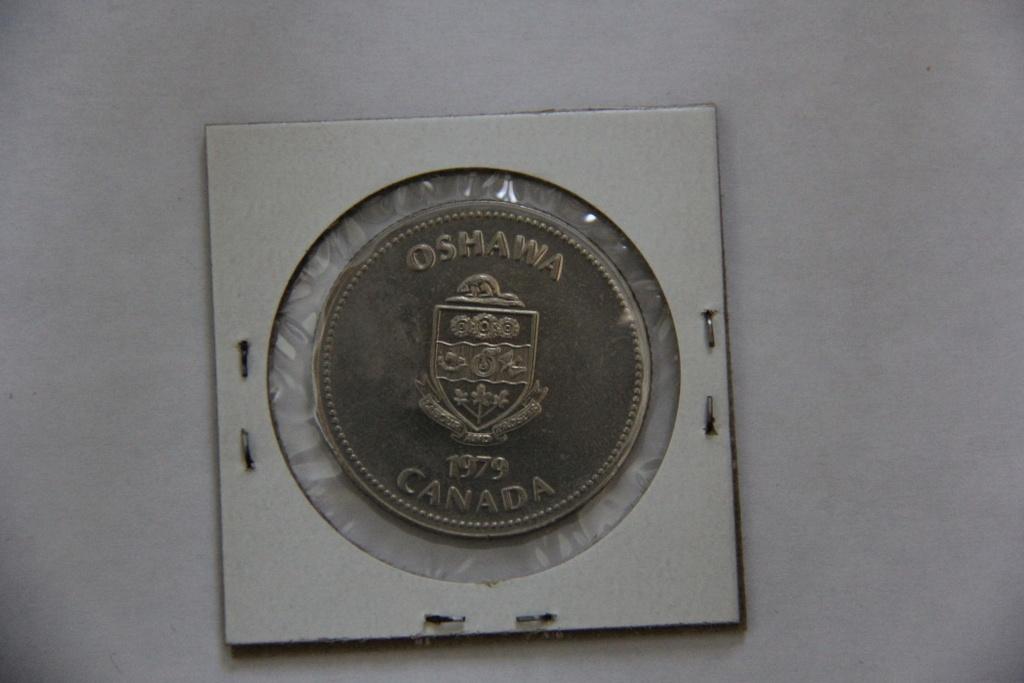What year was the coin produced?
Your response must be concise. 1979. What town in canada is this coin from?
Give a very brief answer. Oshawa. 